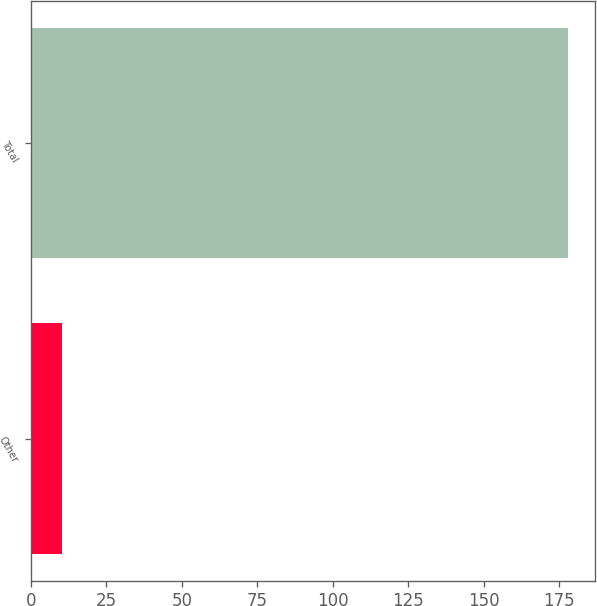Convert chart. <chart><loc_0><loc_0><loc_500><loc_500><bar_chart><fcel>Other<fcel>Total<nl><fcel>10.4<fcel>177.9<nl></chart> 